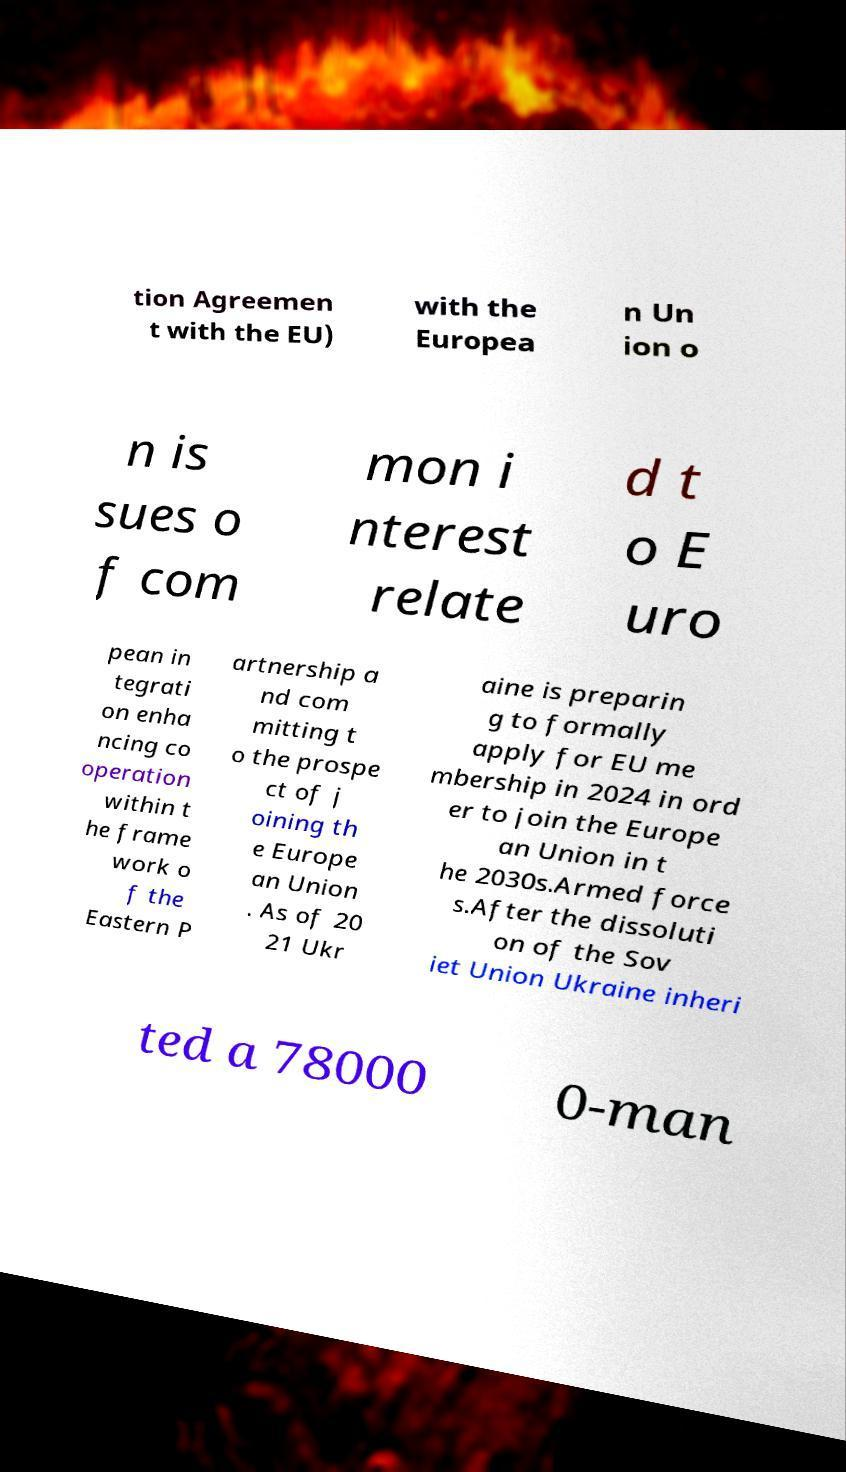Could you assist in decoding the text presented in this image and type it out clearly? tion Agreemen t with the EU) with the Europea n Un ion o n is sues o f com mon i nterest relate d t o E uro pean in tegrati on enha ncing co operation within t he frame work o f the Eastern P artnership a nd com mitting t o the prospe ct of j oining th e Europe an Union . As of 20 21 Ukr aine is preparin g to formally apply for EU me mbership in 2024 in ord er to join the Europe an Union in t he 2030s.Armed force s.After the dissoluti on of the Sov iet Union Ukraine inheri ted a 78000 0-man 